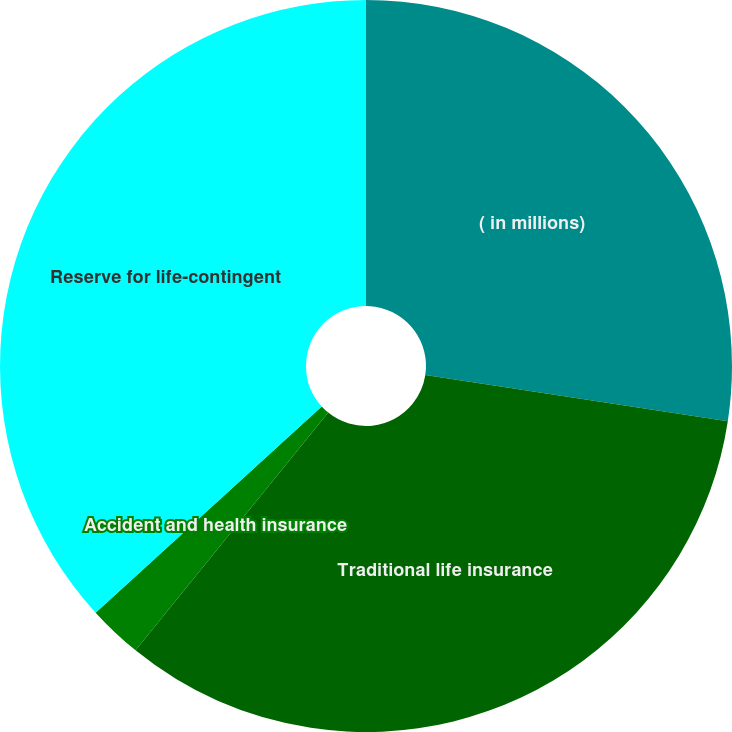Convert chart to OTSL. <chart><loc_0><loc_0><loc_500><loc_500><pie_chart><fcel>( in millions)<fcel>Traditional life insurance<fcel>Accident and health insurance<fcel>Reserve for life-contingent<nl><fcel>27.41%<fcel>33.43%<fcel>2.39%<fcel>36.77%<nl></chart> 